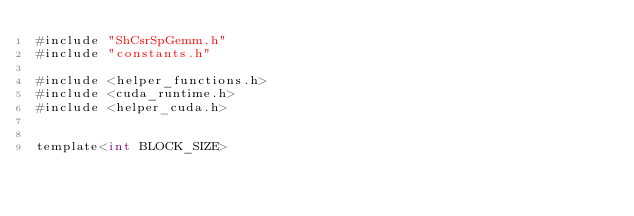<code> <loc_0><loc_0><loc_500><loc_500><_Cuda_>#include "ShCsrSpGemm.h"
#include "constants.h"

#include <helper_functions.h>
#include <cuda_runtime.h>
#include <helper_cuda.h>


template<int BLOCK_SIZE></code> 